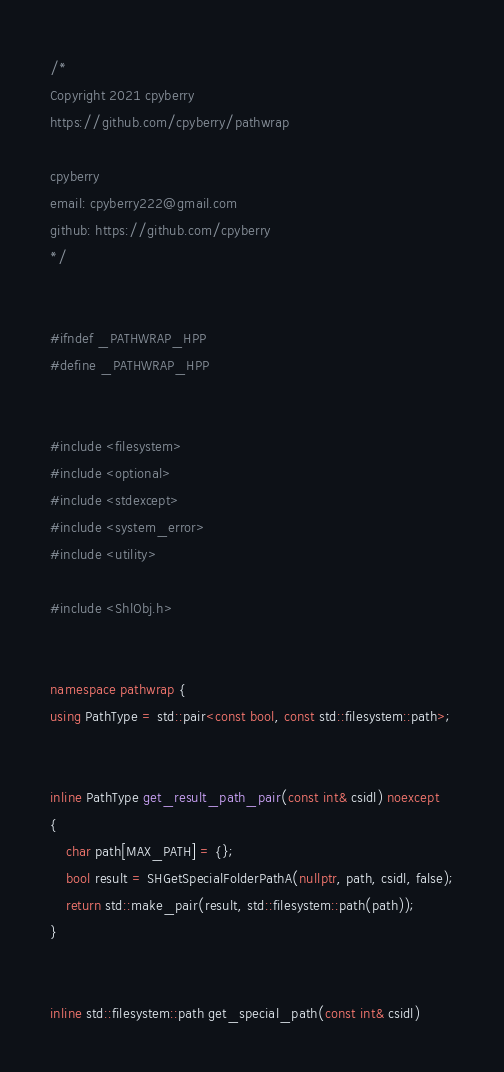Convert code to text. <code><loc_0><loc_0><loc_500><loc_500><_C++_>/*
Copyright 2021 cpyberry
https://github.com/cpyberry/pathwrap

cpyberry
email: cpyberry222@gmail.com
github: https://github.com/cpyberry
*/


#ifndef _PATHWRAP_HPP
#define _PATHWRAP_HPP


#include <filesystem>
#include <optional>
#include <stdexcept>
#include <system_error>
#include <utility>

#include <ShlObj.h>


namespace pathwrap {
using PathType = std::pair<const bool, const std::filesystem::path>;


inline PathType get_result_path_pair(const int& csidl) noexcept
{
	char path[MAX_PATH] = {};
	bool result = SHGetSpecialFolderPathA(nullptr, path, csidl, false);
	return std::make_pair(result, std::filesystem::path(path));
}


inline std::filesystem::path get_special_path(const int& csidl)</code> 